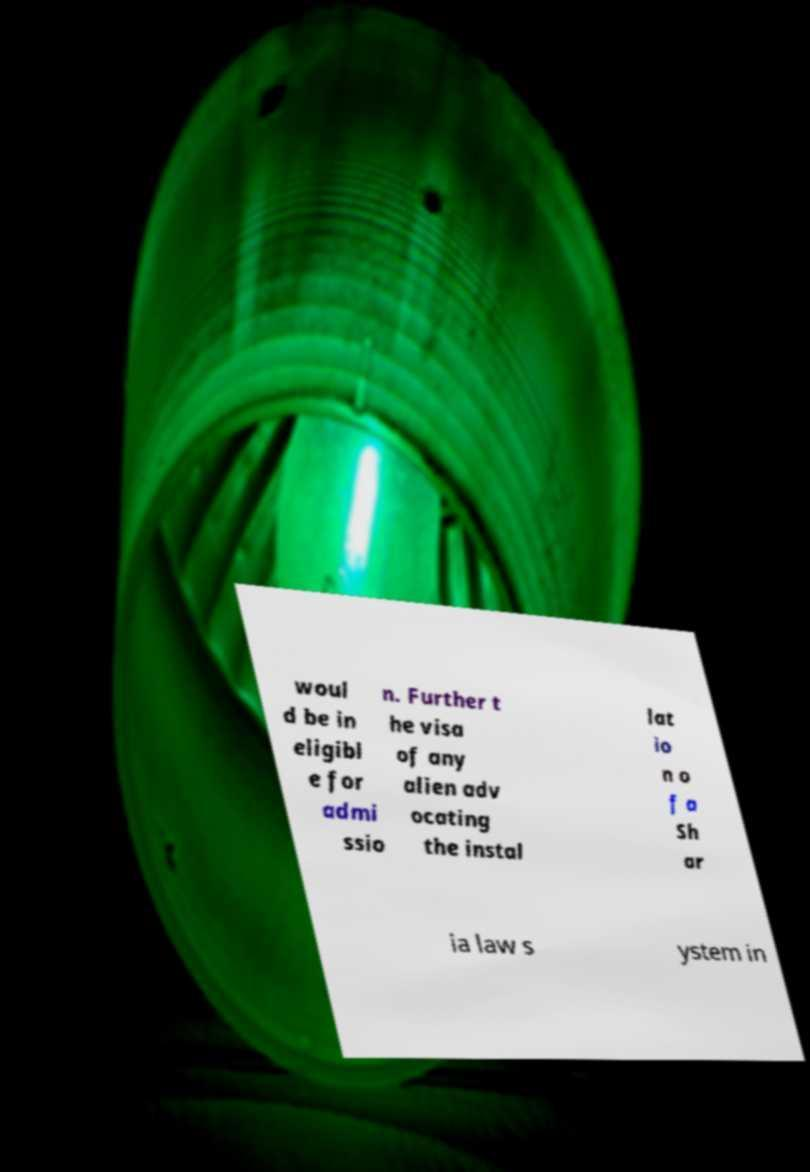Could you extract and type out the text from this image? woul d be in eligibl e for admi ssio n. Further t he visa of any alien adv ocating the instal lat io n o f a Sh ar ia law s ystem in 